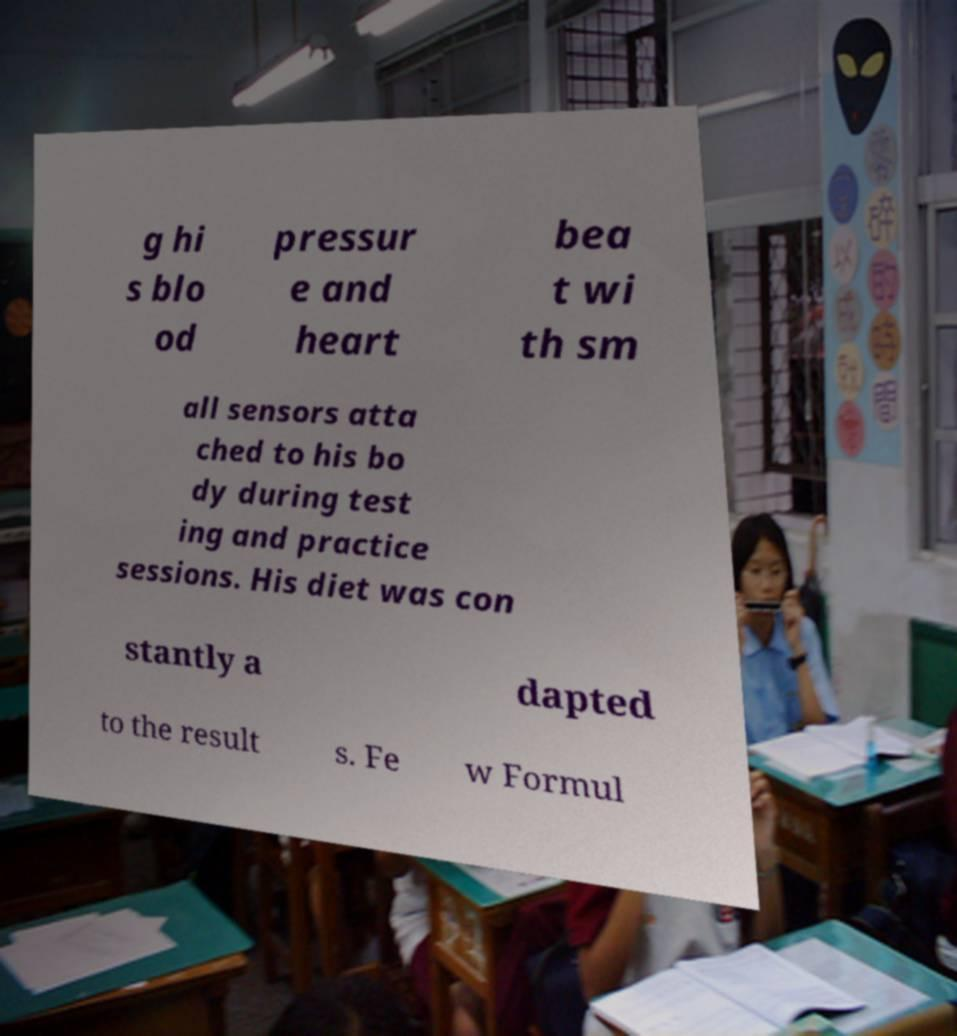For documentation purposes, I need the text within this image transcribed. Could you provide that? g hi s blo od pressur e and heart bea t wi th sm all sensors atta ched to his bo dy during test ing and practice sessions. His diet was con stantly a dapted to the result s. Fe w Formul 